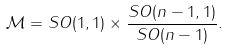Convert formula to latex. <formula><loc_0><loc_0><loc_500><loc_500>\mathcal { M } = S O ( 1 , 1 ) \times \frac { S O ( n - 1 , 1 ) } { S O ( n - 1 ) } .</formula> 